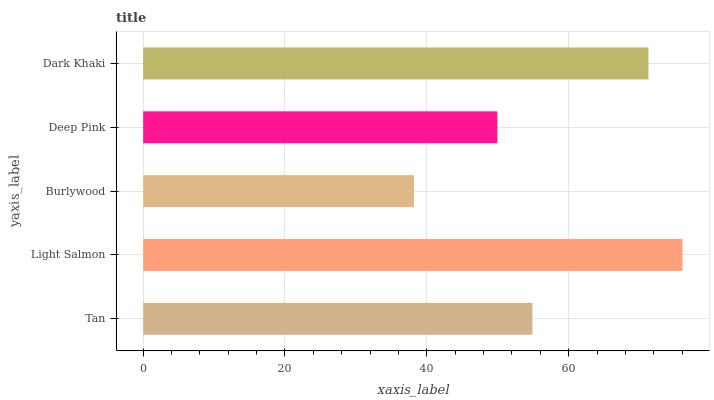Is Burlywood the minimum?
Answer yes or no. Yes. Is Light Salmon the maximum?
Answer yes or no. Yes. Is Light Salmon the minimum?
Answer yes or no. No. Is Burlywood the maximum?
Answer yes or no. No. Is Light Salmon greater than Burlywood?
Answer yes or no. Yes. Is Burlywood less than Light Salmon?
Answer yes or no. Yes. Is Burlywood greater than Light Salmon?
Answer yes or no. No. Is Light Salmon less than Burlywood?
Answer yes or no. No. Is Tan the high median?
Answer yes or no. Yes. Is Tan the low median?
Answer yes or no. Yes. Is Dark Khaki the high median?
Answer yes or no. No. Is Dark Khaki the low median?
Answer yes or no. No. 